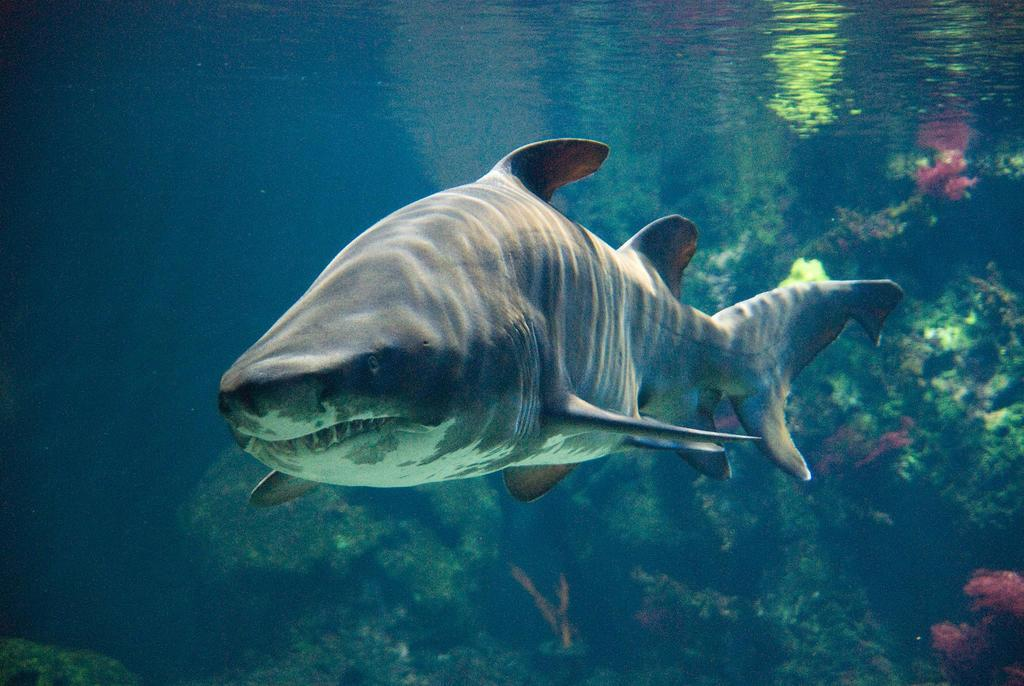What animal is the main subject of the image? There is a whale in the image. Where is the whale located? The whale is underwater. What type of health insurance does the secretary recommend for the whale in the image? There is no secretary or health insurance mentioned in the image; it only features a whale underwater. 